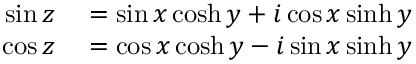Convert formula to latex. <formula><loc_0><loc_0><loc_500><loc_500>\begin{array} { r l } { \sin z } & = \sin x \cosh y + i \cos x \sinh y } \\ { \cos z } & = \cos x \cosh y - i \sin x \sinh y } \end{array}</formula> 